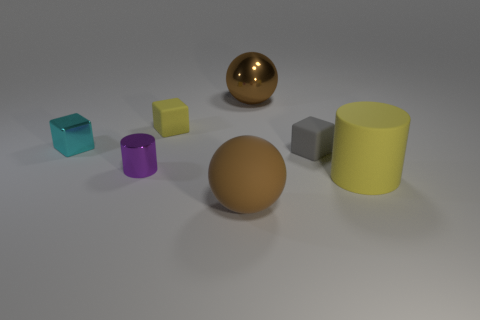There is a sphere behind the brown sphere to the left of the large brown ball that is behind the tiny cyan thing; what is its material?
Ensure brevity in your answer.  Metal. How many other shiny blocks are the same size as the cyan cube?
Offer a very short reply. 0. What material is the small thing that is both left of the yellow rubber block and behind the small metal cylinder?
Ensure brevity in your answer.  Metal. What number of brown matte objects are in front of the big cylinder?
Offer a terse response. 1. Does the big brown metal object have the same shape as the large thing in front of the big yellow matte cylinder?
Make the answer very short. Yes. Is there a gray object of the same shape as the small yellow rubber object?
Make the answer very short. Yes. There is a big object that is on the left side of the large object that is behind the purple shiny object; what is its shape?
Ensure brevity in your answer.  Sphere. What shape is the shiny object behind the small yellow rubber thing?
Your response must be concise. Sphere. There is a matte thing in front of the big cylinder; is its color the same as the metal object behind the small cyan metal block?
Your answer should be very brief. Yes. What number of tiny objects are both in front of the tiny cyan metal thing and on the right side of the small cylinder?
Your answer should be very brief. 1. 